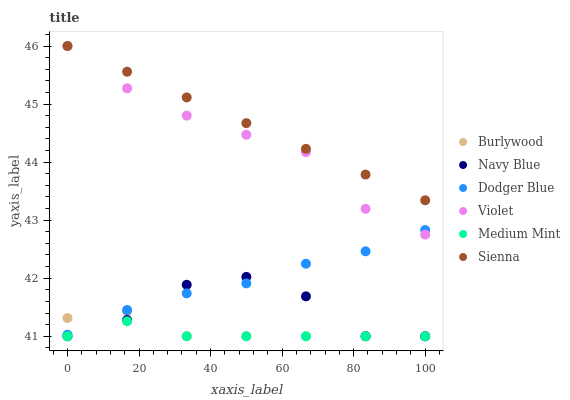Does Medium Mint have the minimum area under the curve?
Answer yes or no. Yes. Does Sienna have the maximum area under the curve?
Answer yes or no. Yes. Does Burlywood have the minimum area under the curve?
Answer yes or no. No. Does Burlywood have the maximum area under the curve?
Answer yes or no. No. Is Sienna the smoothest?
Answer yes or no. Yes. Is Navy Blue the roughest?
Answer yes or no. Yes. Is Burlywood the smoothest?
Answer yes or no. No. Is Burlywood the roughest?
Answer yes or no. No. Does Medium Mint have the lowest value?
Answer yes or no. Yes. Does Sienna have the lowest value?
Answer yes or no. No. Does Violet have the highest value?
Answer yes or no. Yes. Does Burlywood have the highest value?
Answer yes or no. No. Is Burlywood less than Violet?
Answer yes or no. Yes. Is Dodger Blue greater than Medium Mint?
Answer yes or no. Yes. Does Sienna intersect Violet?
Answer yes or no. Yes. Is Sienna less than Violet?
Answer yes or no. No. Is Sienna greater than Violet?
Answer yes or no. No. Does Burlywood intersect Violet?
Answer yes or no. No. 